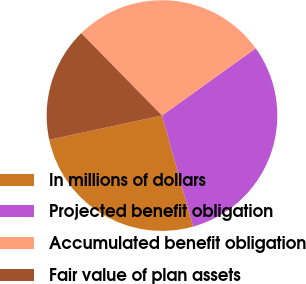Convert chart. <chart><loc_0><loc_0><loc_500><loc_500><pie_chart><fcel>In millions of dollars<fcel>Projected benefit obligation<fcel>Accumulated benefit obligation<fcel>Fair value of plan assets<nl><fcel>25.98%<fcel>30.55%<fcel>27.44%<fcel>16.03%<nl></chart> 